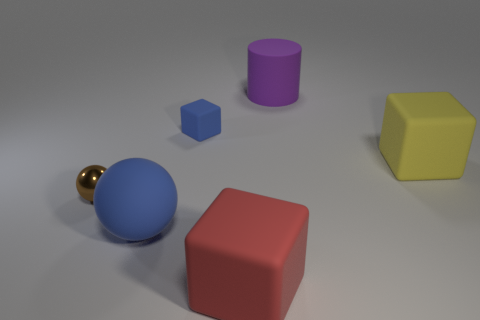Subtract all large rubber cubes. How many cubes are left? 1 Add 3 small matte blocks. How many objects exist? 9 Subtract all yellow cubes. How many cubes are left? 2 Subtract all balls. How many objects are left? 4 Subtract 1 spheres. How many spheres are left? 1 Subtract all blue cylinders. Subtract all purple balls. How many cylinders are left? 1 Subtract all brown rubber cubes. Subtract all purple matte cylinders. How many objects are left? 5 Add 5 tiny blue blocks. How many tiny blue blocks are left? 6 Add 5 small gray cubes. How many small gray cubes exist? 5 Subtract 0 cyan balls. How many objects are left? 6 